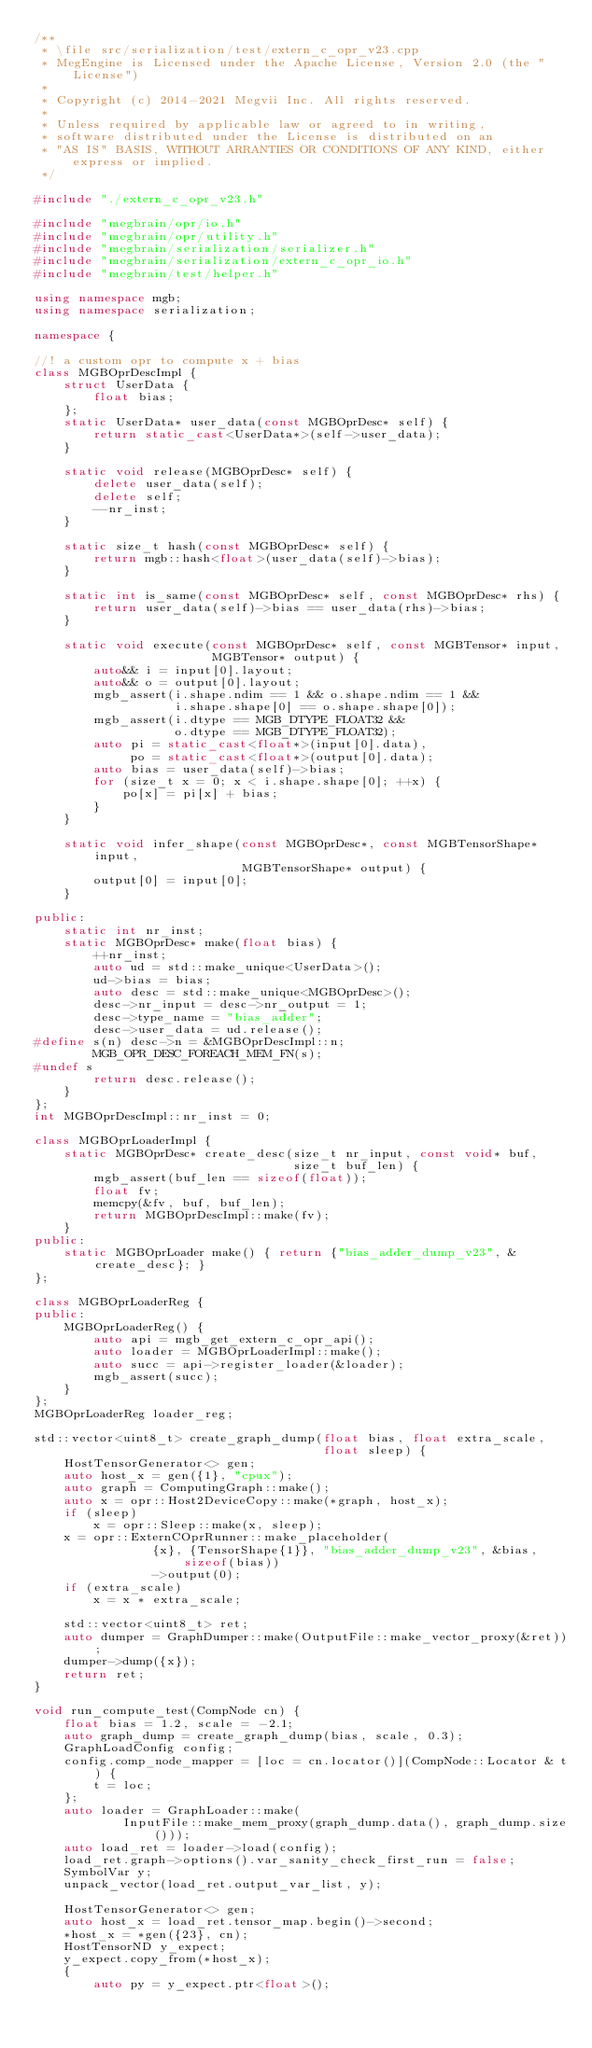Convert code to text. <code><loc_0><loc_0><loc_500><loc_500><_C++_>/**
 * \file src/serialization/test/extern_c_opr_v23.cpp
 * MegEngine is Licensed under the Apache License, Version 2.0 (the "License")
 *
 * Copyright (c) 2014-2021 Megvii Inc. All rights reserved.
 *
 * Unless required by applicable law or agreed to in writing,
 * software distributed under the License is distributed on an
 * "AS IS" BASIS, WITHOUT ARRANTIES OR CONDITIONS OF ANY KIND, either express or implied.
 */

#include "./extern_c_opr_v23.h"

#include "megbrain/opr/io.h"
#include "megbrain/opr/utility.h"
#include "megbrain/serialization/serializer.h"
#include "megbrain/serialization/extern_c_opr_io.h"
#include "megbrain/test/helper.h"

using namespace mgb;
using namespace serialization;

namespace {

//! a custom opr to compute x + bias
class MGBOprDescImpl {
    struct UserData {
        float bias;
    };
    static UserData* user_data(const MGBOprDesc* self) {
        return static_cast<UserData*>(self->user_data);
    }

    static void release(MGBOprDesc* self) {
        delete user_data(self);
        delete self;
        --nr_inst;
    }

    static size_t hash(const MGBOprDesc* self) {
        return mgb::hash<float>(user_data(self)->bias);
    }

    static int is_same(const MGBOprDesc* self, const MGBOprDesc* rhs) {
        return user_data(self)->bias == user_data(rhs)->bias;
    }

    static void execute(const MGBOprDesc* self, const MGBTensor* input,
                        MGBTensor* output) {
        auto&& i = input[0].layout;
        auto&& o = output[0].layout;
        mgb_assert(i.shape.ndim == 1 && o.shape.ndim == 1 &&
                   i.shape.shape[0] == o.shape.shape[0]);
        mgb_assert(i.dtype == MGB_DTYPE_FLOAT32 &&
                   o.dtype == MGB_DTYPE_FLOAT32);
        auto pi = static_cast<float*>(input[0].data),
             po = static_cast<float*>(output[0].data);
        auto bias = user_data(self)->bias;
        for (size_t x = 0; x < i.shape.shape[0]; ++x) {
            po[x] = pi[x] + bias;
        }
    }

    static void infer_shape(const MGBOprDesc*, const MGBTensorShape* input,
                            MGBTensorShape* output) {
        output[0] = input[0];
    }

public:
    static int nr_inst;
    static MGBOprDesc* make(float bias) {
        ++nr_inst;
        auto ud = std::make_unique<UserData>();
        ud->bias = bias;
        auto desc = std::make_unique<MGBOprDesc>();
        desc->nr_input = desc->nr_output = 1;
        desc->type_name = "bias_adder";
        desc->user_data = ud.release();
#define s(n) desc->n = &MGBOprDescImpl::n;
        MGB_OPR_DESC_FOREACH_MEM_FN(s);
#undef s
        return desc.release();
    }
};
int MGBOprDescImpl::nr_inst = 0;

class MGBOprLoaderImpl {
    static MGBOprDesc* create_desc(size_t nr_input, const void* buf,
                                   size_t buf_len) {
        mgb_assert(buf_len == sizeof(float));
        float fv;
        memcpy(&fv, buf, buf_len);
        return MGBOprDescImpl::make(fv);
    }
public:
    static MGBOprLoader make() { return {"bias_adder_dump_v23", &create_desc}; }
};

class MGBOprLoaderReg {
public:
    MGBOprLoaderReg() {
        auto api = mgb_get_extern_c_opr_api();
        auto loader = MGBOprLoaderImpl::make();
        auto succ = api->register_loader(&loader);
        mgb_assert(succ);
    }
};
MGBOprLoaderReg loader_reg;

std::vector<uint8_t> create_graph_dump(float bias, float extra_scale,
                                       float sleep) {
    HostTensorGenerator<> gen;
    auto host_x = gen({1}, "cpux");
    auto graph = ComputingGraph::make();
    auto x = opr::Host2DeviceCopy::make(*graph, host_x);
    if (sleep)
        x = opr::Sleep::make(x, sleep);
    x = opr::ExternCOprRunner::make_placeholder(
                {x}, {TensorShape{1}}, "bias_adder_dump_v23", &bias, sizeof(bias))
                ->output(0);
    if (extra_scale)
        x = x * extra_scale;

    std::vector<uint8_t> ret;
    auto dumper = GraphDumper::make(OutputFile::make_vector_proxy(&ret));
    dumper->dump({x});
    return ret;
}

void run_compute_test(CompNode cn) {
    float bias = 1.2, scale = -2.1;
    auto graph_dump = create_graph_dump(bias, scale, 0.3);
    GraphLoadConfig config;
    config.comp_node_mapper = [loc = cn.locator()](CompNode::Locator & t) {
        t = loc;
    };
    auto loader = GraphLoader::make(
            InputFile::make_mem_proxy(graph_dump.data(), graph_dump.size()));
    auto load_ret = loader->load(config);
    load_ret.graph->options().var_sanity_check_first_run = false;
    SymbolVar y;
    unpack_vector(load_ret.output_var_list, y);

    HostTensorGenerator<> gen;
    auto host_x = load_ret.tensor_map.begin()->second;
    *host_x = *gen({23}, cn);
    HostTensorND y_expect;
    y_expect.copy_from(*host_x);
    {
        auto py = y_expect.ptr<float>();</code> 